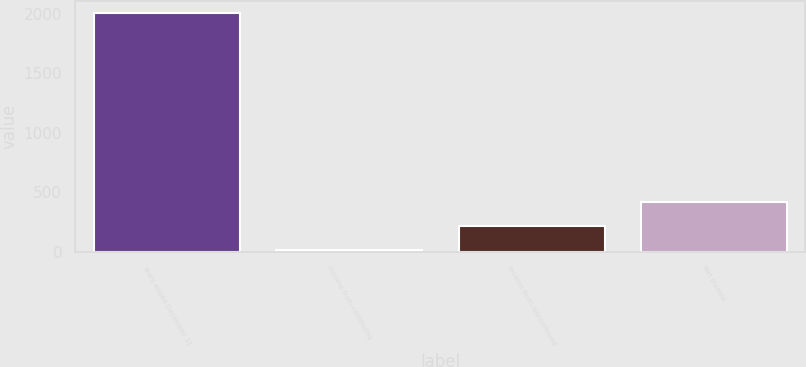Convert chart. <chart><loc_0><loc_0><loc_500><loc_500><bar_chart><fcel>Years ended December 31<fcel>Income from continuing<fcel>Income from discontinued<fcel>Net income<nl><fcel>2008<fcel>15<fcel>214.3<fcel>413.6<nl></chart> 